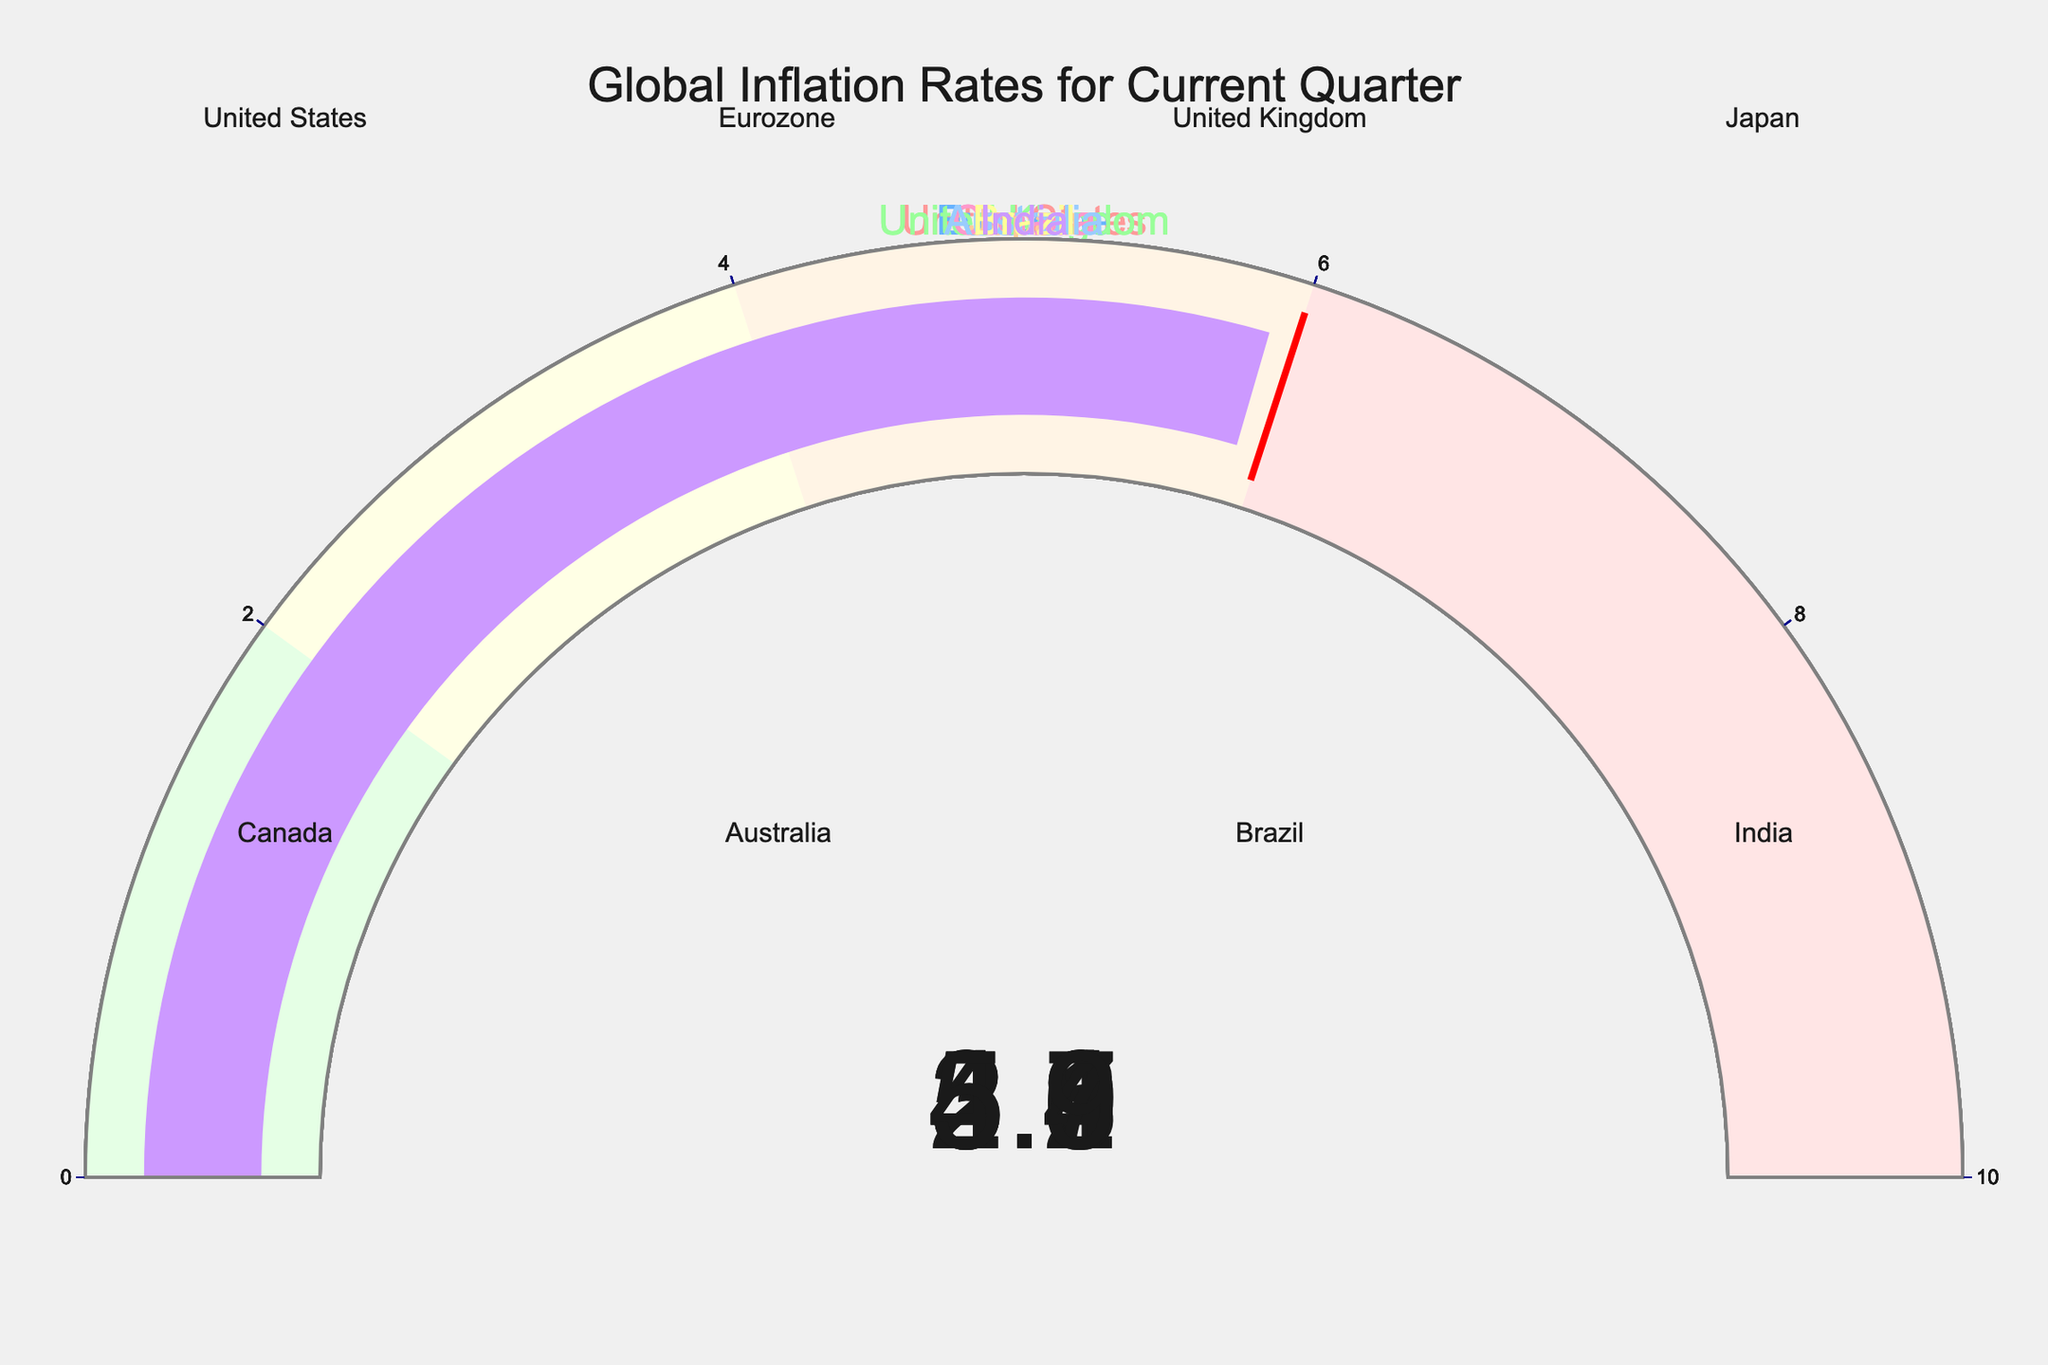What's the inflation rate for the United States? The gauge for the United States shows a single number, which is the current quarter's inflation rate.
Answer: 3.2 Which country has the highest inflation rate? Compare the values on each gauge to determine which one has the largest number. Australia has an inflation rate of 5.4, which is the highest among all countries listed.
Answer: Australia Compare the inflation rates of Canada and Brazil. Which country has a higher rate? The gauge for Canada shows 3.8, and the gauge for Brazil shows 4.7. Since 4.7 is greater than 3.8, Brazil has a higher inflation rate than Canada.
Answer: Brazil What's the average inflation rate across all the countries shown? Add up all the inflation rates (3.2 + 2.9 + 4.6 + 2.1 + 3.8 + 5.4 + 4.7 + 5.9) which equals 32.6. Divide this sum by the number of countries (8) to get the average: 32.6 / 8 = 4.075
Answer: 4.075 Is Japan's inflation rate below the threshold value? The threshold value is set at 6. The gauge for Japan shows an inflation rate of 2.1, which is below this threshold.
Answer: Yes How many countries have inflation rates above 4? Observing the gauges, the countries with inflation rates above 4 are the United Kingdom (4.6), Australia (5.4), Brazil (4.7), and India (5.9), totaling 4 countries.
Answer: 4 What is the color associated with the inflation rate for the Eurozone? The Eurozone gauge uses a specific color, which is the second one on the custom color scale provided. This color is a light blue shade.
Answer: Light blue Calculate the difference in inflation rates between India and Japan. The inflation rate for India is 5.9, and for Japan, it is 2.1. The difference is calculated as 5.9 - 2.1 = 3.8.
Answer: 3.8 Which country has an inflation rate closest to the overall average rate? The overall average rate is 4.075. Comparing each rate to this average, the United Kingdom with an inflation rate of 4.6 is the closest.
Answer: United Kingdom What range of the gauge does Australia's inflation rate fall into? Australia's inflation rate is 5.4, which falls into the range of [4, 6] shaded in light orange in the gauge chart.
Answer: [4, 6] 